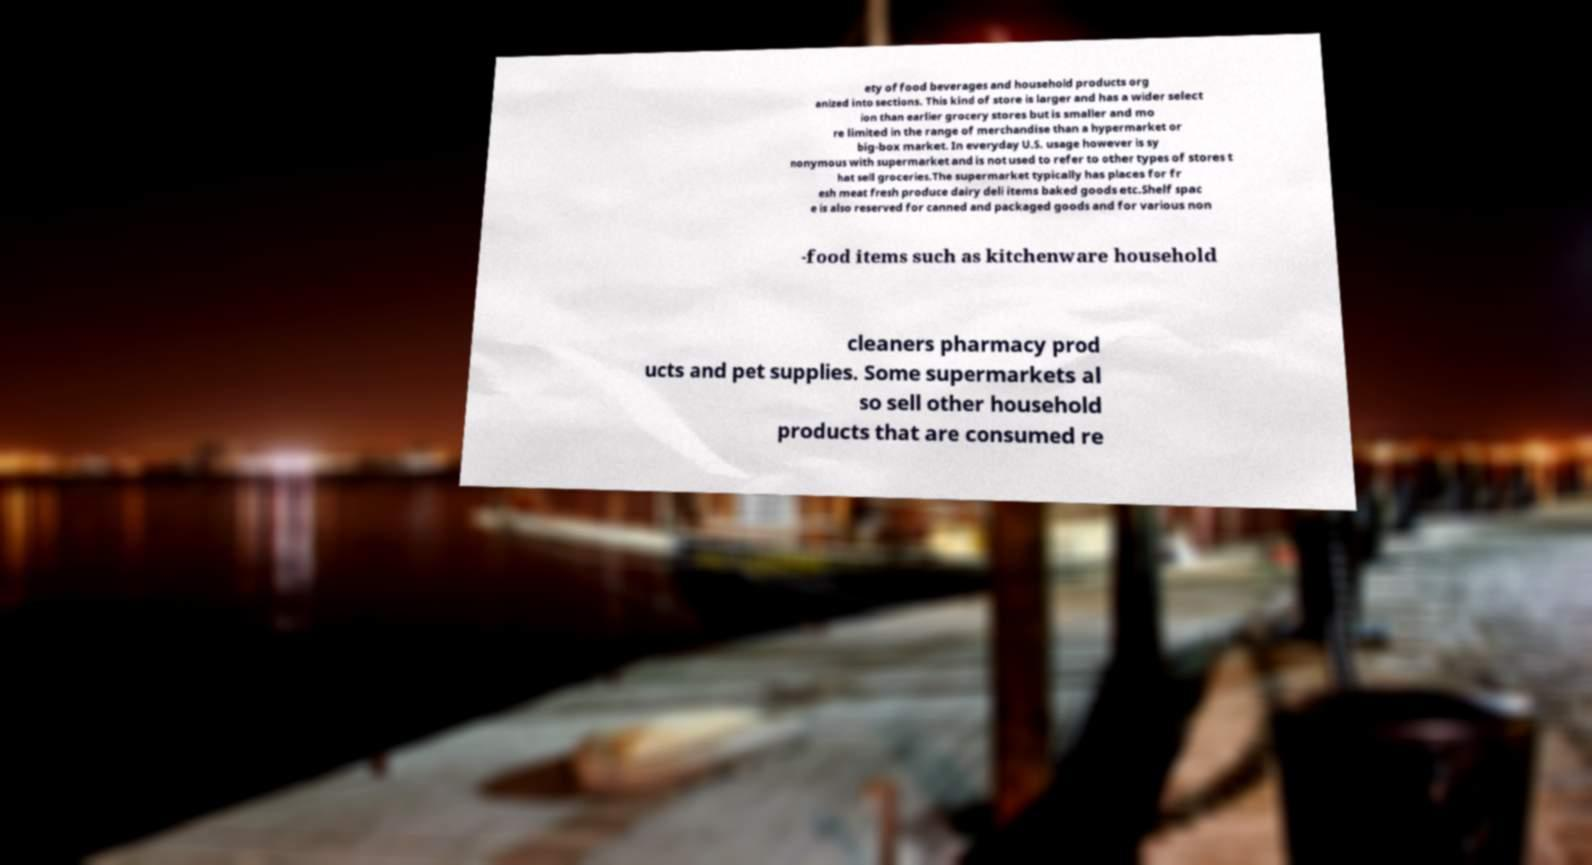Could you extract and type out the text from this image? ety of food beverages and household products org anized into sections. This kind of store is larger and has a wider select ion than earlier grocery stores but is smaller and mo re limited in the range of merchandise than a hypermarket or big-box market. In everyday U.S. usage however is sy nonymous with supermarket and is not used to refer to other types of stores t hat sell groceries.The supermarket typically has places for fr esh meat fresh produce dairy deli items baked goods etc.Shelf spac e is also reserved for canned and packaged goods and for various non -food items such as kitchenware household cleaners pharmacy prod ucts and pet supplies. Some supermarkets al so sell other household products that are consumed re 